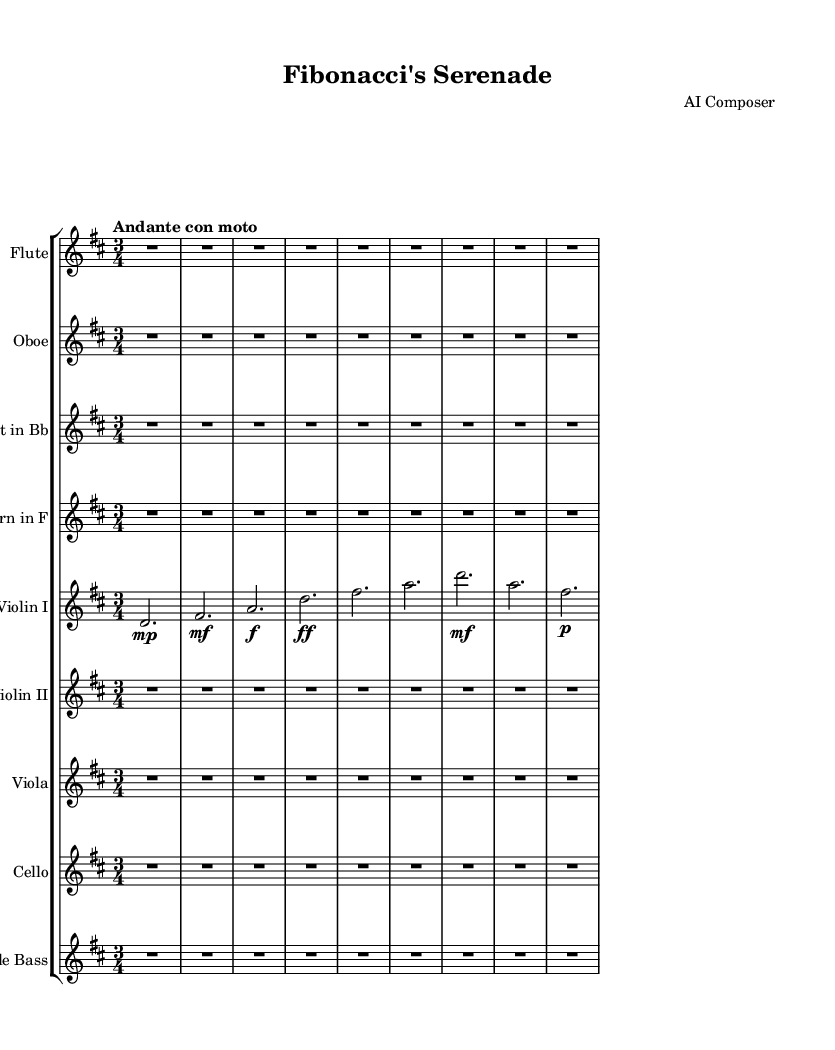What is the key signature of this music? The key signature is indicated by the number of sharps or flats at the beginning of the staff. In this case, D major has two sharps (F# and C#), which are not shown as accidentals throughout the piece.
Answer: D major What is the time signature of this music? The time signature is shown at the beginning of the score, and it is indicated by two numbers stacked on top of each other. Here, the time signature is 3/4, meaning there are three beats per measure.
Answer: 3/4 What is the tempo marking? The tempo marking is specified with the term "Andante con moto," suggesting a moderately slow and flowing pace. This can be found near the beginning of the score, indicating how quickly the piece should be played.
Answer: Andante con moto Which instrument has a transposition indicated? The instruments that have a transposition indicated are listed with their specific transpositions in their respective parts. The Clarinet in B flat is notated with a "transposition bes," which means it sounds a whole step lower than what is written.
Answer: Clarinet in B flat What dynamics are indicated for Violin I during the first few measures? The dynamics are indicated by the markings next to the notes. In the indicated measures for Violin I, it starts with a "mp" (mezzo-piano), then "mf" (mezzo-forte), and then "f" (forte), which shows a gradual increase in volume.
Answer: mp, mf, f Why might this composition be referred to as "Fibonacci's Serenade"? The title suggests an artistic connection to the Fibonacci sequence, which is known for its mathematical beauty and presence in nature. The title might imply that the musical phrases or structures reflect this pattern of growth, echoing the sequence's characteristics.
Answer: Fibonacci sequence 